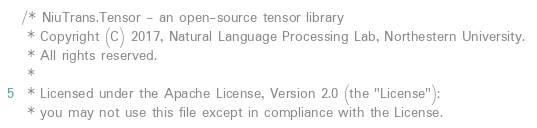<code> <loc_0><loc_0><loc_500><loc_500><_Cuda_>/* NiuTrans.Tensor - an open-source tensor library
 * Copyright (C) 2017, Natural Language Processing Lab, Northestern University. 
 * All rights reserved.
 *
 * Licensed under the Apache License, Version 2.0 (the "License");
 * you may not use this file except in compliance with the License.</code> 